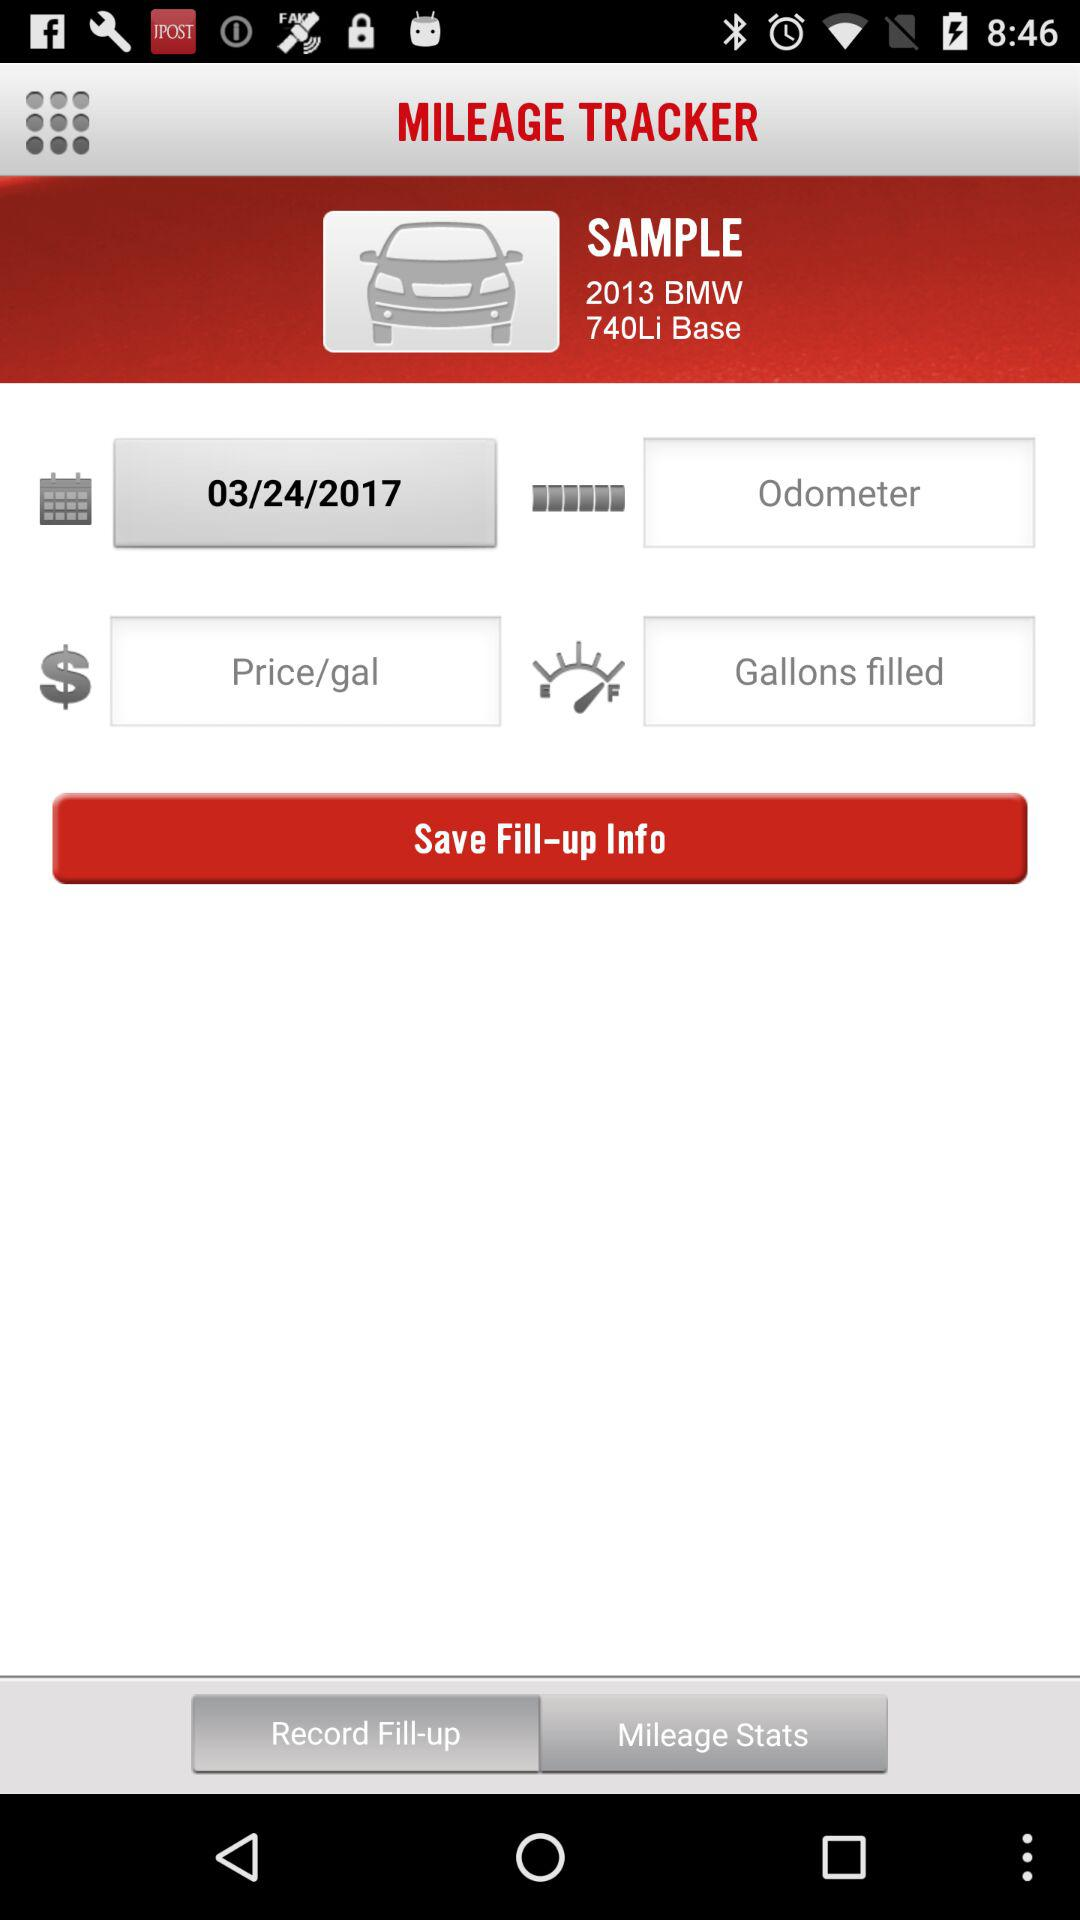How much is the gallon price of gasoline?
When the provided information is insufficient, respond with <no answer>. <no answer> 